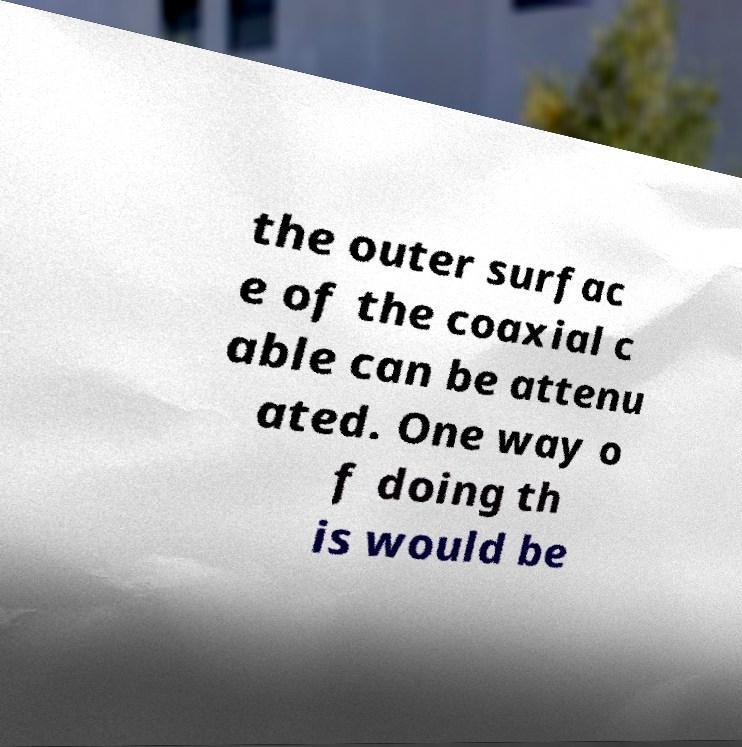For documentation purposes, I need the text within this image transcribed. Could you provide that? the outer surfac e of the coaxial c able can be attenu ated. One way o f doing th is would be 